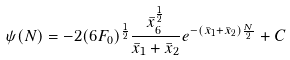<formula> <loc_0><loc_0><loc_500><loc_500>\psi ( N ) = - 2 ( 6 F _ { 0 } ) ^ { \frac { 1 } { 2 } } \frac { \bar { x } _ { 6 } ^ { \frac { 1 } { 2 } } } { \bar { x } _ { 1 } + \bar { x } _ { 2 } } e ^ { - ( \bar { x } _ { 1 } + \bar { x } _ { 2 } ) \frac { N } { 2 } } + C</formula> 